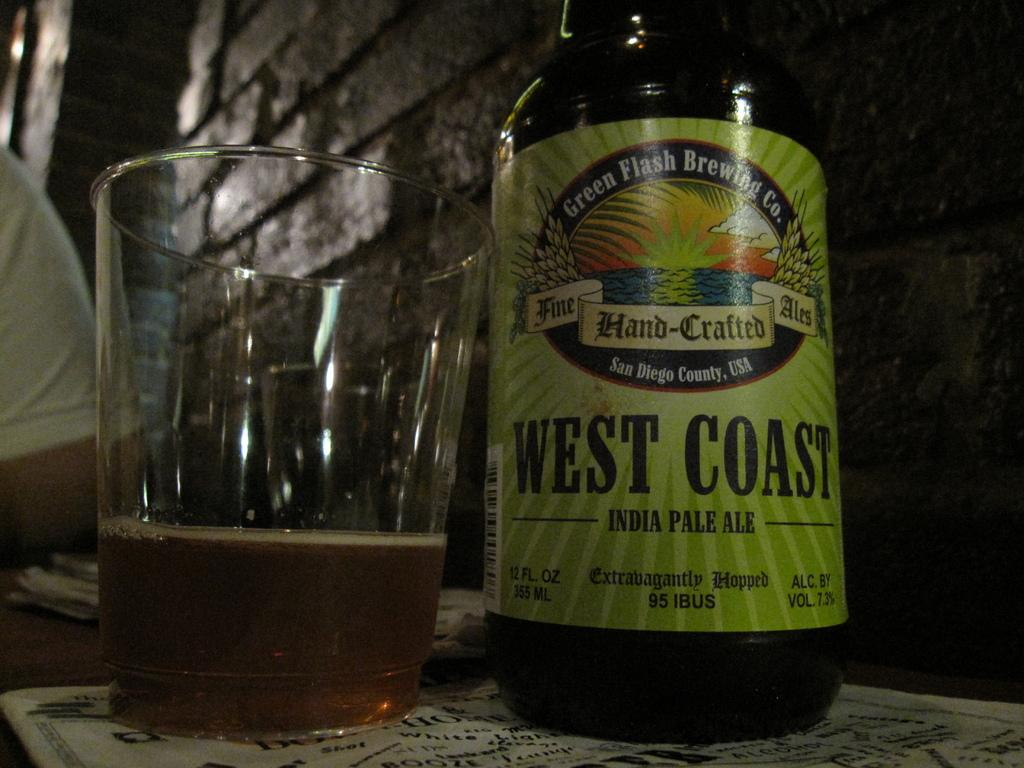<image>
Share a concise interpretation of the image provided. A bottle of West Coast pale ale has a bright green label. 